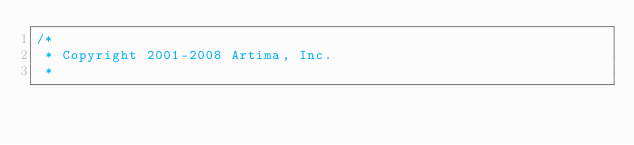<code> <loc_0><loc_0><loc_500><loc_500><_Scala_>/*
 * Copyright 2001-2008 Artima, Inc.
 *</code> 